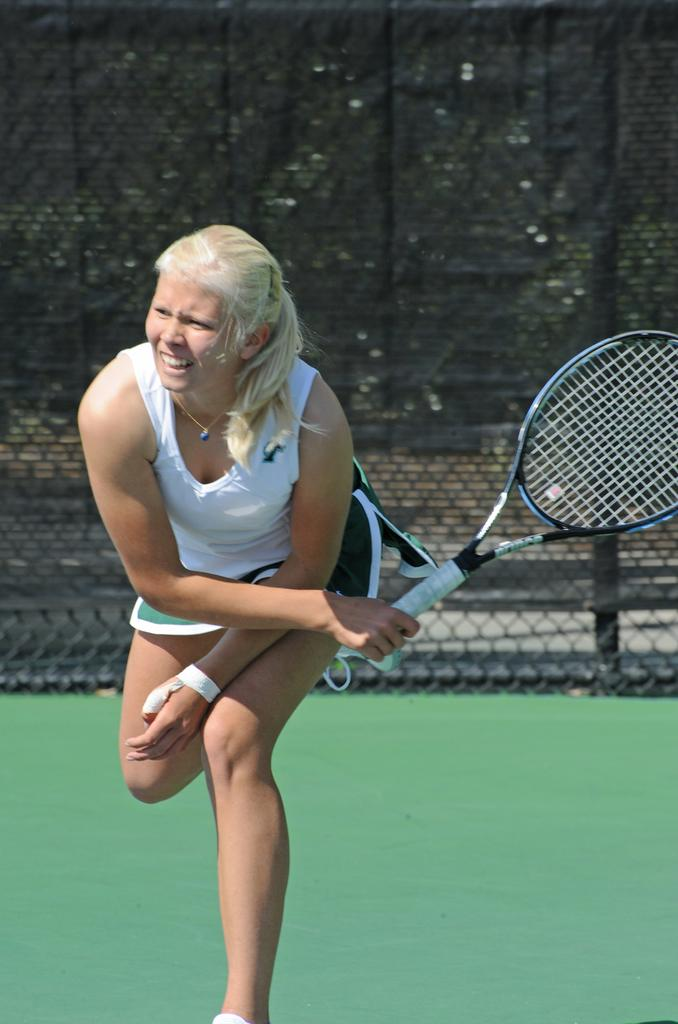Who or what is present in the image? There is a person in the image. What is the person doing in the image? The person is standing in the image. What object is the person holding in her hand? The person is holding a racket in her hand. What can be seen behind the person? There is a fencing behind the person. What is visible beyond the fencing? There are trees behind the fencing. What type of tray is being used by the person in the image? There is no tray present in the image; the person is holding a racket. 